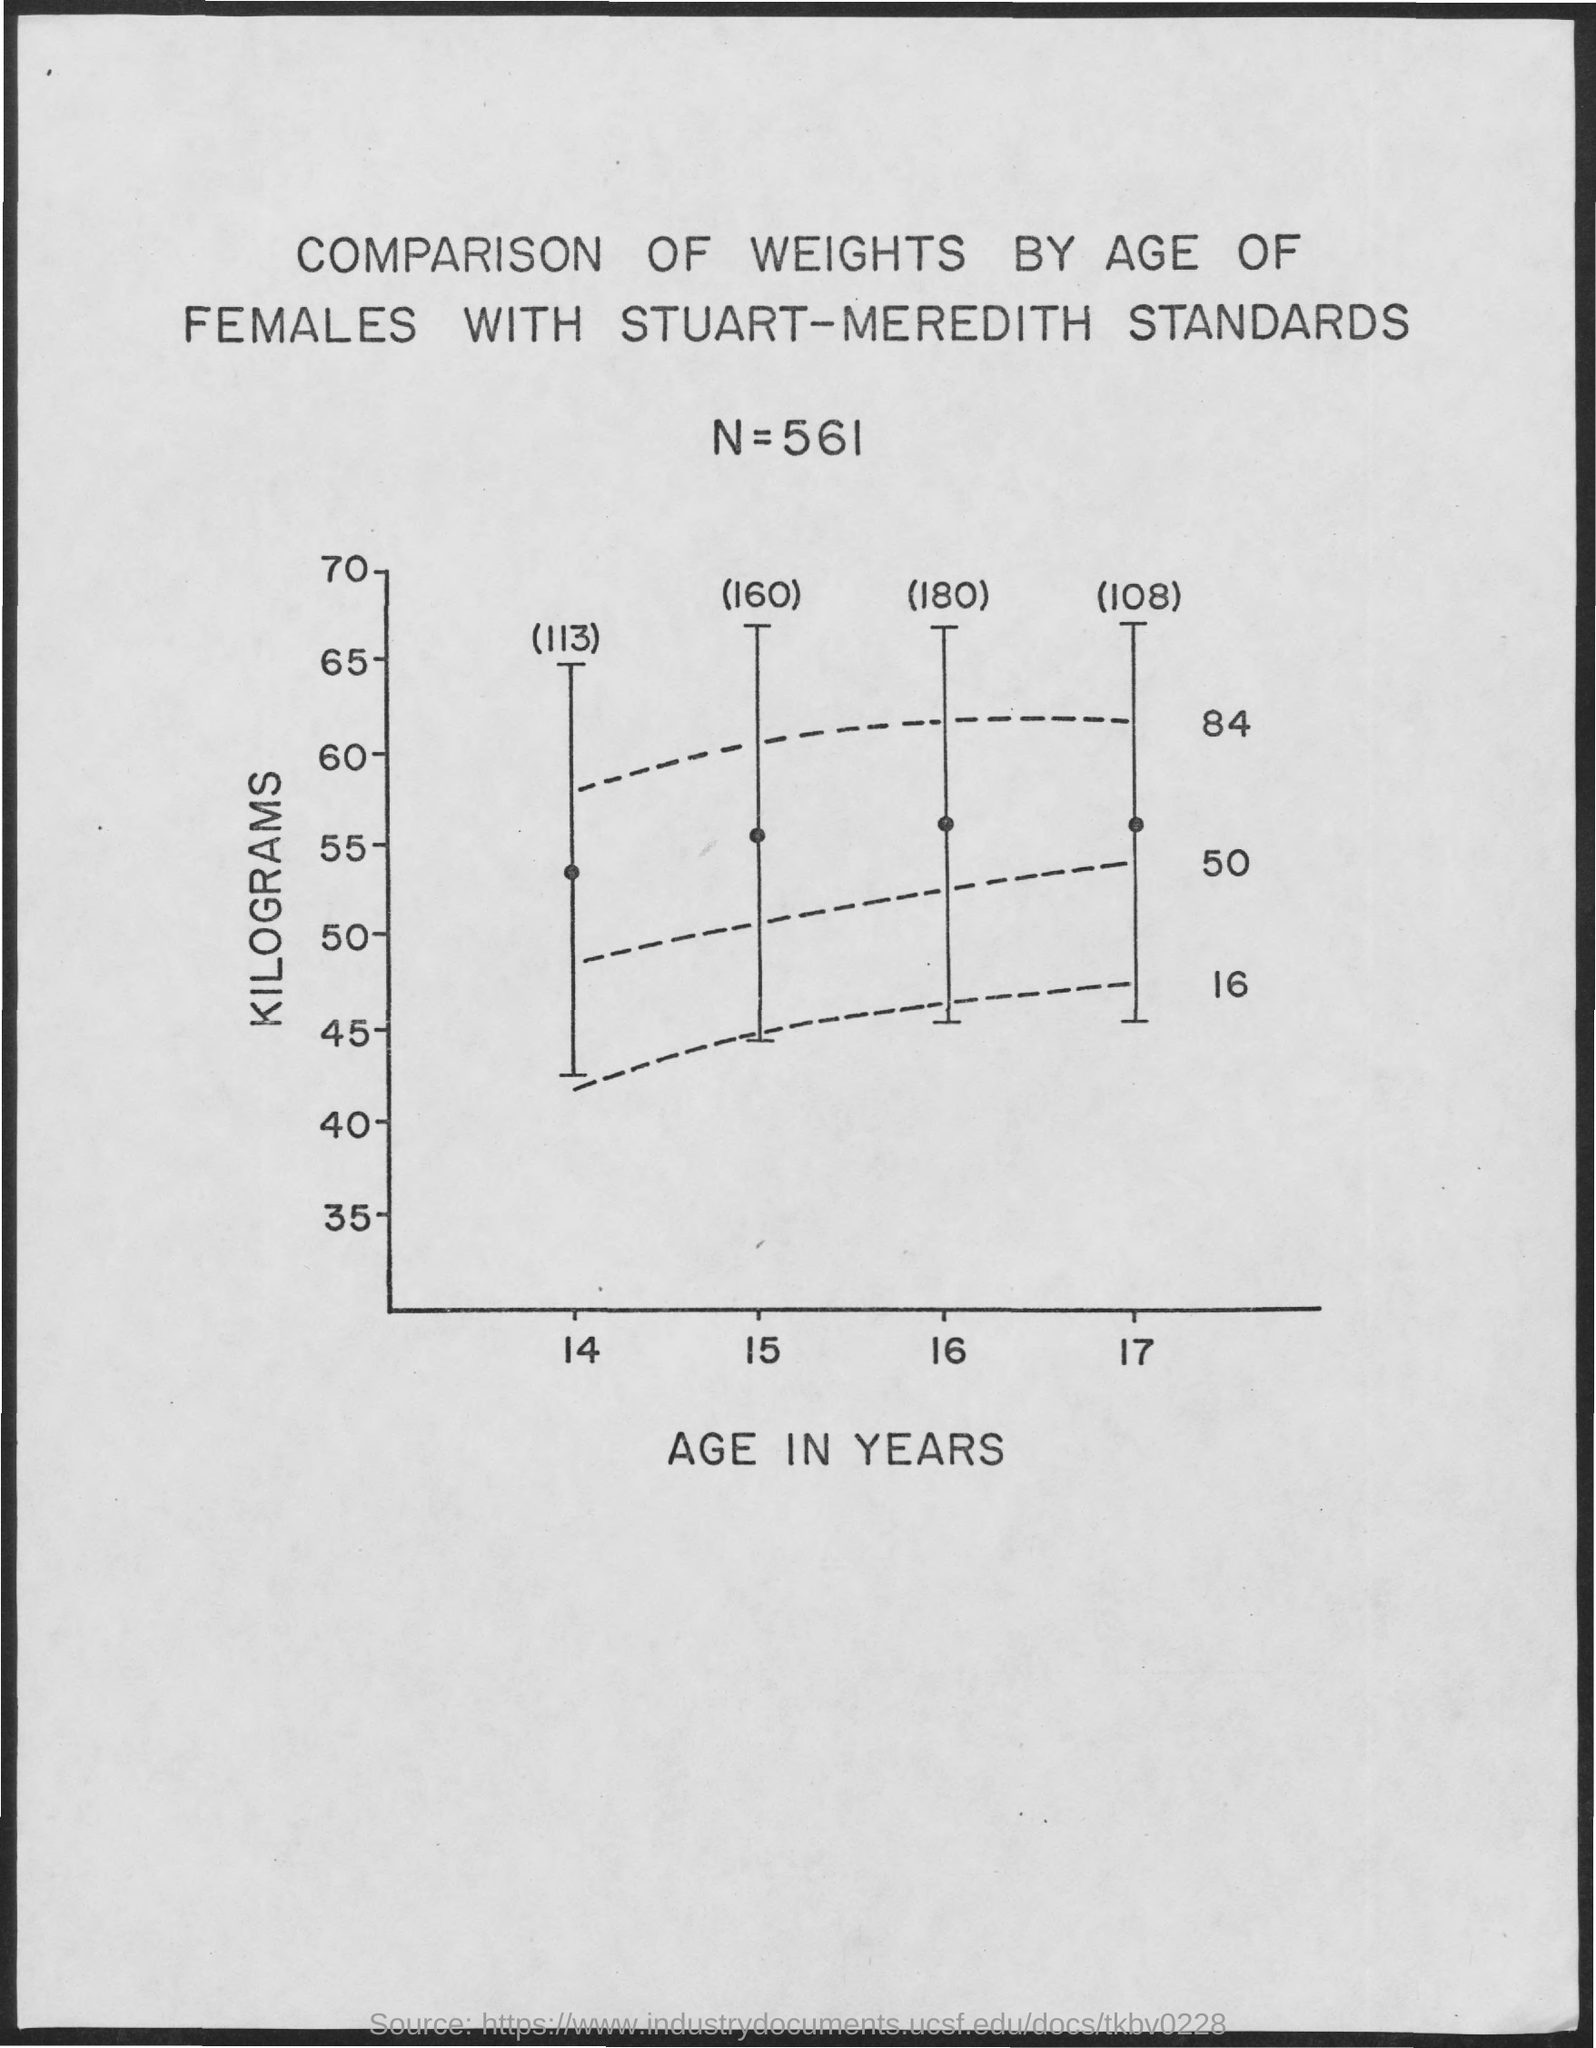Give some essential details in this illustration. The x-axis in the given scatter plot displays age in years, which is plotted to show the relationship between age and the frequency of visits to the doctor. The standard used to plot the graph is the Stuart-Meredith standard. The y-axis represents the weight in kilograms. 